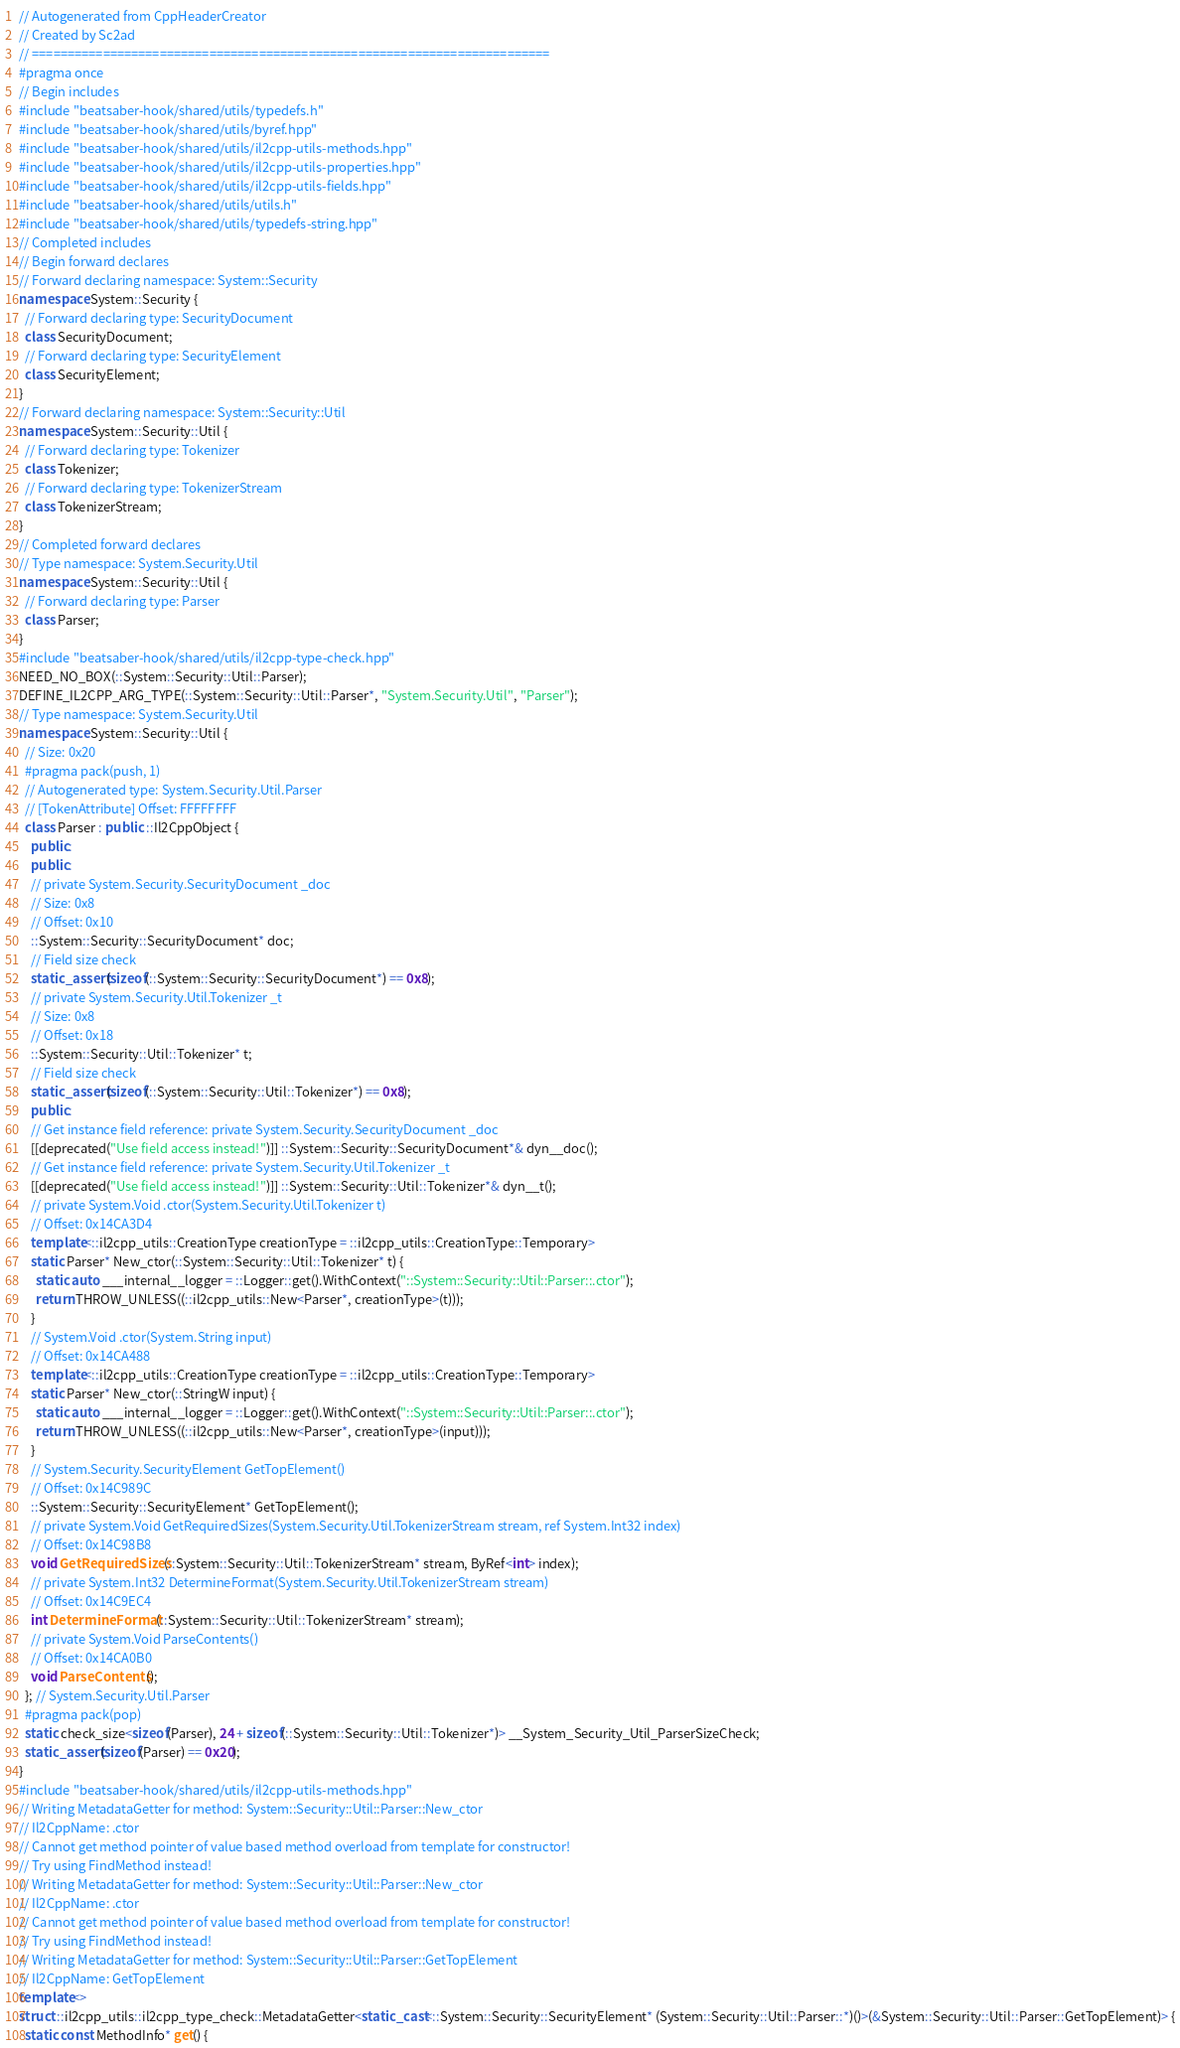Convert code to text. <code><loc_0><loc_0><loc_500><loc_500><_C++_>// Autogenerated from CppHeaderCreator
// Created by Sc2ad
// =========================================================================
#pragma once
// Begin includes
#include "beatsaber-hook/shared/utils/typedefs.h"
#include "beatsaber-hook/shared/utils/byref.hpp"
#include "beatsaber-hook/shared/utils/il2cpp-utils-methods.hpp"
#include "beatsaber-hook/shared/utils/il2cpp-utils-properties.hpp"
#include "beatsaber-hook/shared/utils/il2cpp-utils-fields.hpp"
#include "beatsaber-hook/shared/utils/utils.h"
#include "beatsaber-hook/shared/utils/typedefs-string.hpp"
// Completed includes
// Begin forward declares
// Forward declaring namespace: System::Security
namespace System::Security {
  // Forward declaring type: SecurityDocument
  class SecurityDocument;
  // Forward declaring type: SecurityElement
  class SecurityElement;
}
// Forward declaring namespace: System::Security::Util
namespace System::Security::Util {
  // Forward declaring type: Tokenizer
  class Tokenizer;
  // Forward declaring type: TokenizerStream
  class TokenizerStream;
}
// Completed forward declares
// Type namespace: System.Security.Util
namespace System::Security::Util {
  // Forward declaring type: Parser
  class Parser;
}
#include "beatsaber-hook/shared/utils/il2cpp-type-check.hpp"
NEED_NO_BOX(::System::Security::Util::Parser);
DEFINE_IL2CPP_ARG_TYPE(::System::Security::Util::Parser*, "System.Security.Util", "Parser");
// Type namespace: System.Security.Util
namespace System::Security::Util {
  // Size: 0x20
  #pragma pack(push, 1)
  // Autogenerated type: System.Security.Util.Parser
  // [TokenAttribute] Offset: FFFFFFFF
  class Parser : public ::Il2CppObject {
    public:
    public:
    // private System.Security.SecurityDocument _doc
    // Size: 0x8
    // Offset: 0x10
    ::System::Security::SecurityDocument* doc;
    // Field size check
    static_assert(sizeof(::System::Security::SecurityDocument*) == 0x8);
    // private System.Security.Util.Tokenizer _t
    // Size: 0x8
    // Offset: 0x18
    ::System::Security::Util::Tokenizer* t;
    // Field size check
    static_assert(sizeof(::System::Security::Util::Tokenizer*) == 0x8);
    public:
    // Get instance field reference: private System.Security.SecurityDocument _doc
    [[deprecated("Use field access instead!")]] ::System::Security::SecurityDocument*& dyn__doc();
    // Get instance field reference: private System.Security.Util.Tokenizer _t
    [[deprecated("Use field access instead!")]] ::System::Security::Util::Tokenizer*& dyn__t();
    // private System.Void .ctor(System.Security.Util.Tokenizer t)
    // Offset: 0x14CA3D4
    template<::il2cpp_utils::CreationType creationType = ::il2cpp_utils::CreationType::Temporary>
    static Parser* New_ctor(::System::Security::Util::Tokenizer* t) {
      static auto ___internal__logger = ::Logger::get().WithContext("::System::Security::Util::Parser::.ctor");
      return THROW_UNLESS((::il2cpp_utils::New<Parser*, creationType>(t)));
    }
    // System.Void .ctor(System.String input)
    // Offset: 0x14CA488
    template<::il2cpp_utils::CreationType creationType = ::il2cpp_utils::CreationType::Temporary>
    static Parser* New_ctor(::StringW input) {
      static auto ___internal__logger = ::Logger::get().WithContext("::System::Security::Util::Parser::.ctor");
      return THROW_UNLESS((::il2cpp_utils::New<Parser*, creationType>(input)));
    }
    // System.Security.SecurityElement GetTopElement()
    // Offset: 0x14C989C
    ::System::Security::SecurityElement* GetTopElement();
    // private System.Void GetRequiredSizes(System.Security.Util.TokenizerStream stream, ref System.Int32 index)
    // Offset: 0x14C98B8
    void GetRequiredSizes(::System::Security::Util::TokenizerStream* stream, ByRef<int> index);
    // private System.Int32 DetermineFormat(System.Security.Util.TokenizerStream stream)
    // Offset: 0x14C9EC4
    int DetermineFormat(::System::Security::Util::TokenizerStream* stream);
    // private System.Void ParseContents()
    // Offset: 0x14CA0B0
    void ParseContents();
  }; // System.Security.Util.Parser
  #pragma pack(pop)
  static check_size<sizeof(Parser), 24 + sizeof(::System::Security::Util::Tokenizer*)> __System_Security_Util_ParserSizeCheck;
  static_assert(sizeof(Parser) == 0x20);
}
#include "beatsaber-hook/shared/utils/il2cpp-utils-methods.hpp"
// Writing MetadataGetter for method: System::Security::Util::Parser::New_ctor
// Il2CppName: .ctor
// Cannot get method pointer of value based method overload from template for constructor!
// Try using FindMethod instead!
// Writing MetadataGetter for method: System::Security::Util::Parser::New_ctor
// Il2CppName: .ctor
// Cannot get method pointer of value based method overload from template for constructor!
// Try using FindMethod instead!
// Writing MetadataGetter for method: System::Security::Util::Parser::GetTopElement
// Il2CppName: GetTopElement
template<>
struct ::il2cpp_utils::il2cpp_type_check::MetadataGetter<static_cast<::System::Security::SecurityElement* (System::Security::Util::Parser::*)()>(&System::Security::Util::Parser::GetTopElement)> {
  static const MethodInfo* get() {</code> 